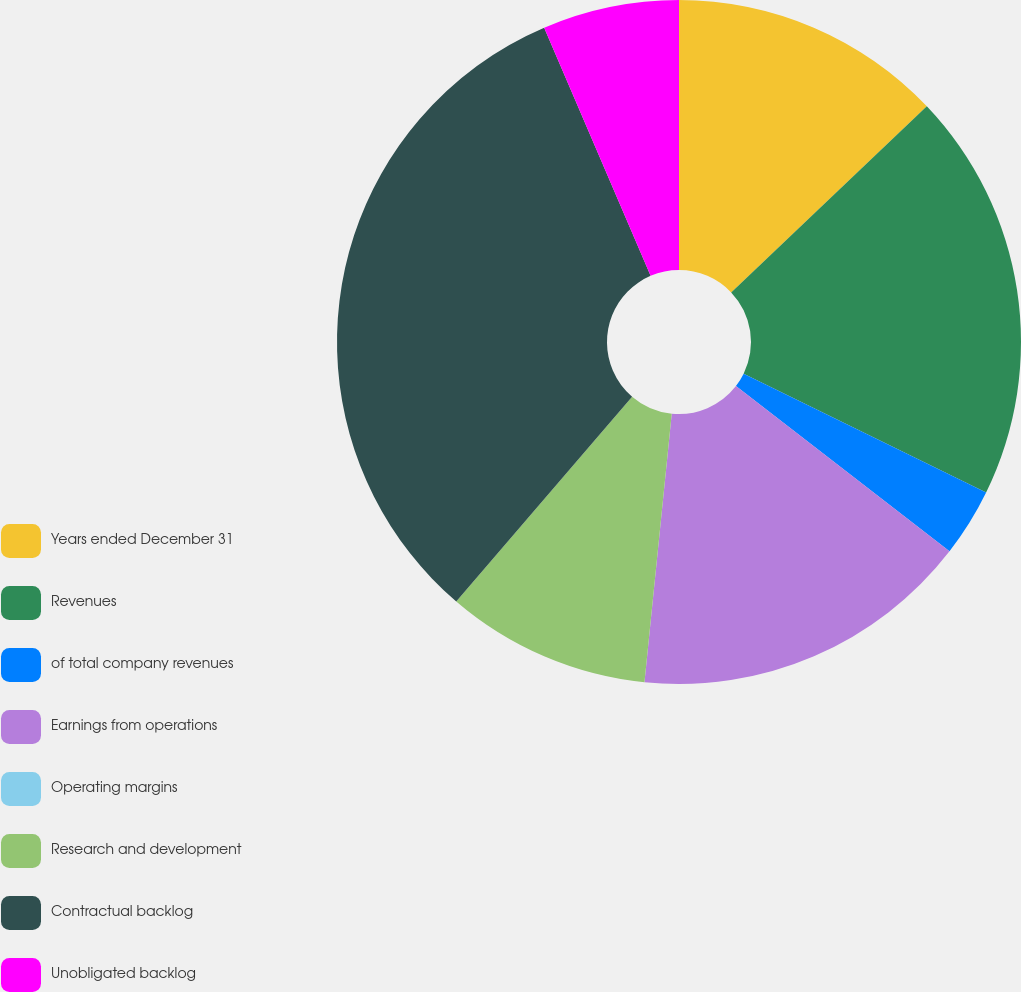Convert chart. <chart><loc_0><loc_0><loc_500><loc_500><pie_chart><fcel>Years ended December 31<fcel>Revenues<fcel>of total company revenues<fcel>Earnings from operations<fcel>Operating margins<fcel>Research and development<fcel>Contractual backlog<fcel>Unobligated backlog<nl><fcel>12.9%<fcel>19.35%<fcel>3.23%<fcel>16.13%<fcel>0.0%<fcel>9.68%<fcel>32.26%<fcel>6.45%<nl></chart> 